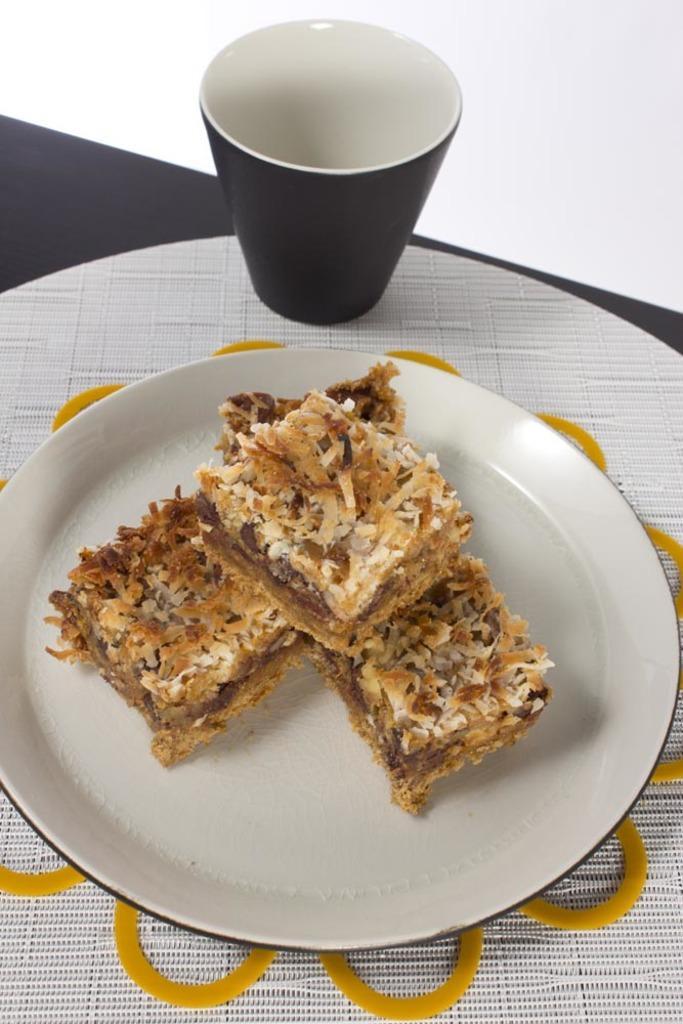How would you summarize this image in a sentence or two? In this image I can see food on the plate and it is placed on the table, and I can see there is a glass on the table. 